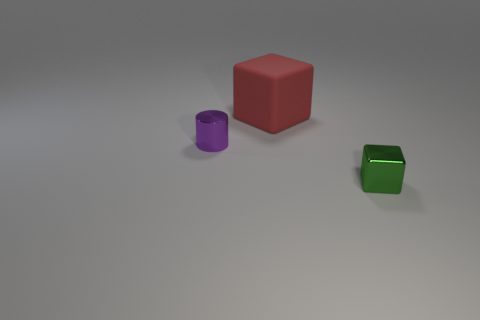What number of other things are there of the same material as the tiny block
Your answer should be very brief. 1. Does the tiny metallic object that is right of the purple cylinder have the same shape as the tiny metal object that is to the left of the green cube?
Give a very brief answer. No. Does the red object have the same material as the cylinder?
Provide a succinct answer. No. There is a block on the left side of the thing in front of the metallic thing behind the tiny metal cube; what size is it?
Give a very brief answer. Large. What number of other objects are there of the same color as the big block?
Provide a short and direct response. 0. What is the shape of the metallic thing that is the same size as the purple metal cylinder?
Ensure brevity in your answer.  Cube. What number of small things are red cylinders or metal cylinders?
Provide a succinct answer. 1. Are there any big matte things that are right of the tiny metal thing that is in front of the tiny metallic thing on the left side of the big red cube?
Provide a succinct answer. No. Is there a metallic cylinder that has the same size as the green object?
Make the answer very short. Yes. What is the material of the cylinder that is the same size as the green thing?
Your answer should be compact. Metal. 